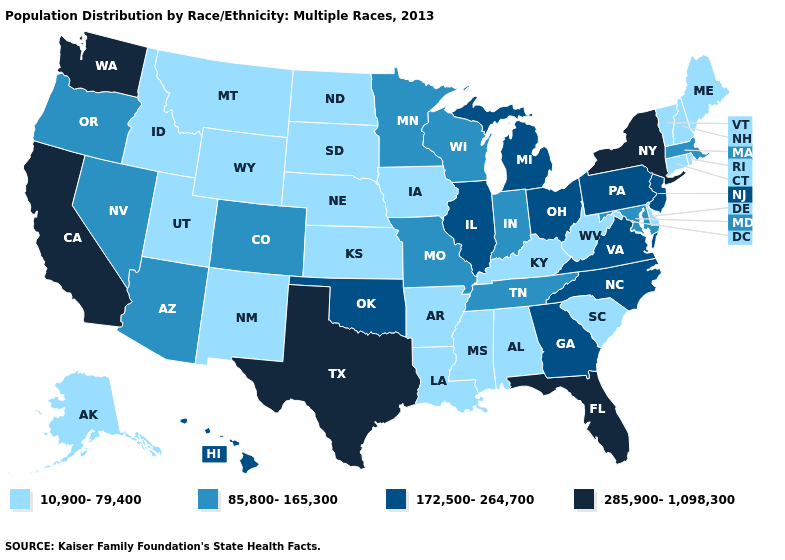Does Utah have the lowest value in the USA?
Give a very brief answer. Yes. Which states have the lowest value in the Northeast?
Quick response, please. Connecticut, Maine, New Hampshire, Rhode Island, Vermont. Name the states that have a value in the range 10,900-79,400?
Write a very short answer. Alabama, Alaska, Arkansas, Connecticut, Delaware, Idaho, Iowa, Kansas, Kentucky, Louisiana, Maine, Mississippi, Montana, Nebraska, New Hampshire, New Mexico, North Dakota, Rhode Island, South Carolina, South Dakota, Utah, Vermont, West Virginia, Wyoming. Which states hav the highest value in the Northeast?
Be succinct. New York. What is the value of Montana?
Be succinct. 10,900-79,400. What is the value of Texas?
Answer briefly. 285,900-1,098,300. What is the lowest value in the West?
Be succinct. 10,900-79,400. Name the states that have a value in the range 172,500-264,700?
Be succinct. Georgia, Hawaii, Illinois, Michigan, New Jersey, North Carolina, Ohio, Oklahoma, Pennsylvania, Virginia. Is the legend a continuous bar?
Quick response, please. No. Does Connecticut have the same value as Rhode Island?
Write a very short answer. Yes. What is the value of Tennessee?
Give a very brief answer. 85,800-165,300. Does Idaho have the same value as Vermont?
Short answer required. Yes. What is the lowest value in states that border Idaho?
Quick response, please. 10,900-79,400. What is the value of Connecticut?
Keep it brief. 10,900-79,400. What is the highest value in the USA?
Answer briefly. 285,900-1,098,300. 